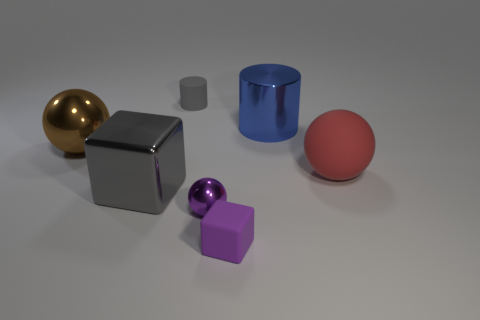Subtract all shiny balls. How many balls are left? 1 Add 1 purple shiny objects. How many objects exist? 8 Subtract all cubes. How many objects are left? 5 Subtract all small purple rubber cubes. Subtract all large blocks. How many objects are left? 5 Add 5 big balls. How many big balls are left? 7 Add 5 tiny purple objects. How many tiny purple objects exist? 7 Subtract 0 red blocks. How many objects are left? 7 